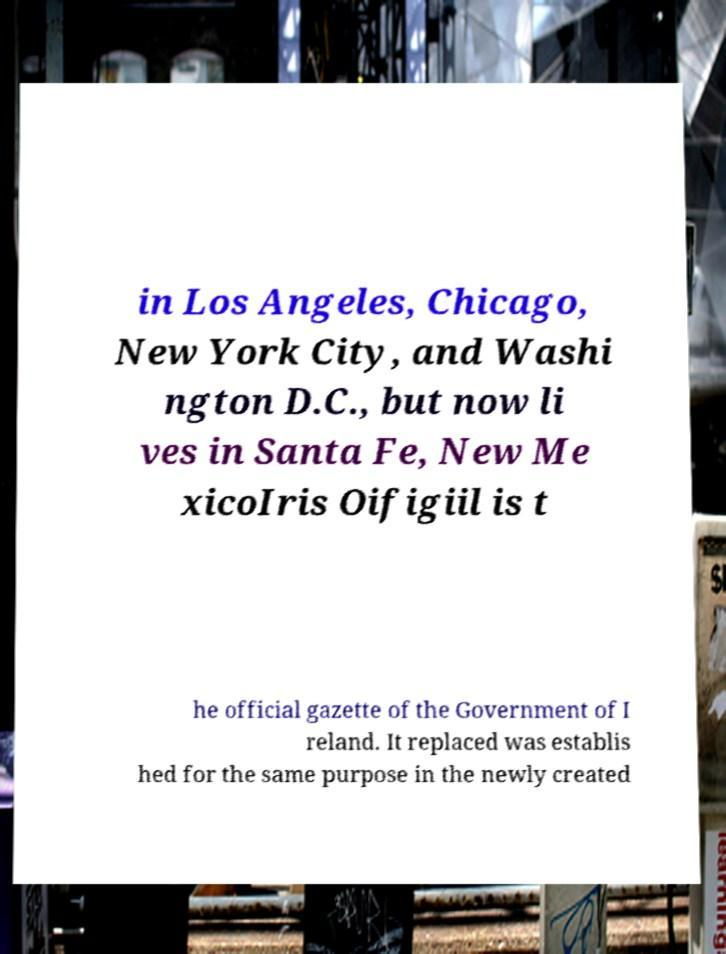Can you accurately transcribe the text from the provided image for me? in Los Angeles, Chicago, New York City, and Washi ngton D.C., but now li ves in Santa Fe, New Me xicoIris Oifigiil is t he official gazette of the Government of I reland. It replaced was establis hed for the same purpose in the newly created 